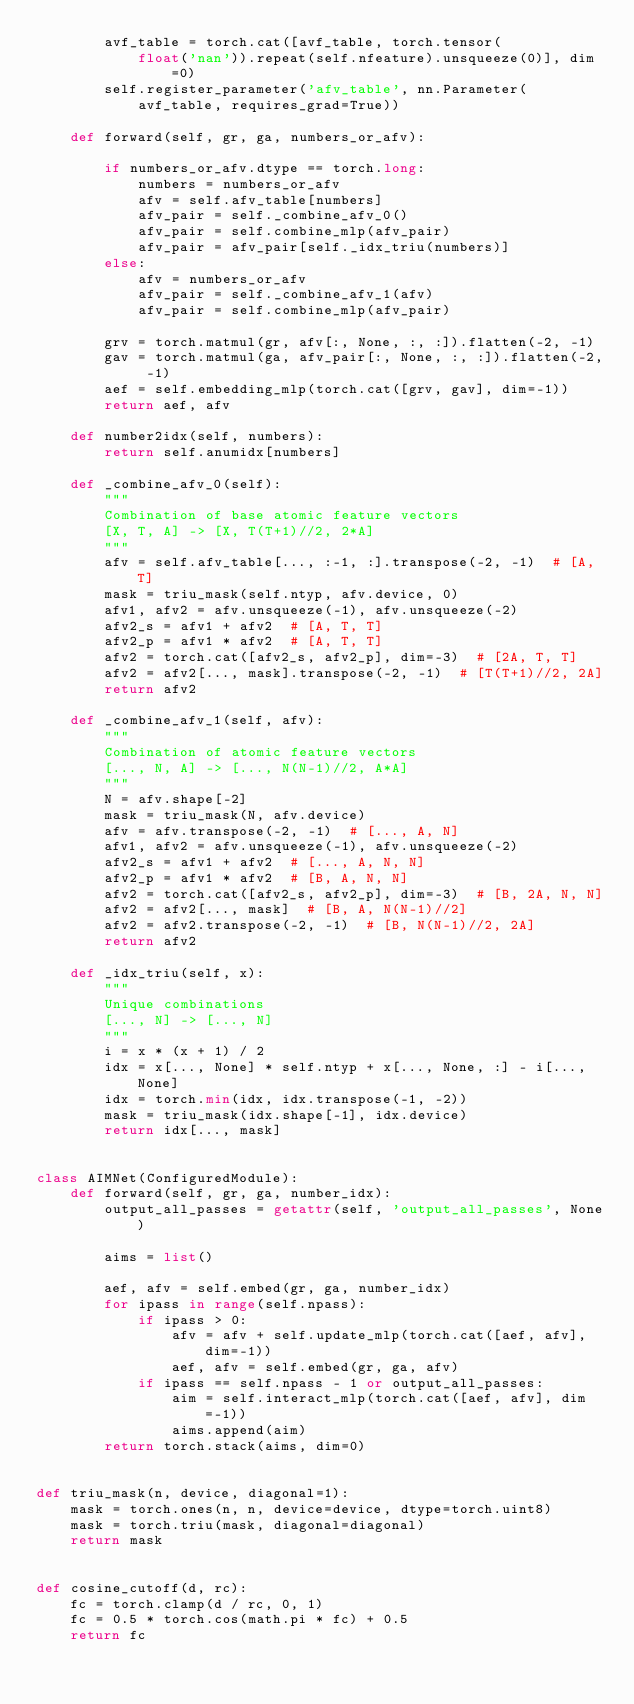Convert code to text. <code><loc_0><loc_0><loc_500><loc_500><_Python_>        avf_table = torch.cat([avf_table, torch.tensor(
            float('nan')).repeat(self.nfeature).unsqueeze(0)], dim=0)
        self.register_parameter('afv_table', nn.Parameter(
            avf_table, requires_grad=True))

    def forward(self, gr, ga, numbers_or_afv):

        if numbers_or_afv.dtype == torch.long:
            numbers = numbers_or_afv
            afv = self.afv_table[numbers]
            afv_pair = self._combine_afv_0()
            afv_pair = self.combine_mlp(afv_pair)
            afv_pair = afv_pair[self._idx_triu(numbers)]
        else:
            afv = numbers_or_afv
            afv_pair = self._combine_afv_1(afv)
            afv_pair = self.combine_mlp(afv_pair)

        grv = torch.matmul(gr, afv[:, None, :, :]).flatten(-2, -1)
        gav = torch.matmul(ga, afv_pair[:, None, :, :]).flatten(-2, -1)
        aef = self.embedding_mlp(torch.cat([grv, gav], dim=-1))
        return aef, afv

    def number2idx(self, numbers):
        return self.anumidx[numbers]

    def _combine_afv_0(self):
        """
        Combination of base atomic feature vectors
        [X, T, A] -> [X, T(T+1)//2, 2*A]
        """
        afv = self.afv_table[..., :-1, :].transpose(-2, -1)  # [A, T]
        mask = triu_mask(self.ntyp, afv.device, 0)
        afv1, afv2 = afv.unsqueeze(-1), afv.unsqueeze(-2)
        afv2_s = afv1 + afv2  # [A, T, T]
        afv2_p = afv1 * afv2  # [A, T, T]
        afv2 = torch.cat([afv2_s, afv2_p], dim=-3)  # [2A, T, T]
        afv2 = afv2[..., mask].transpose(-2, -1)  # [T(T+1)//2, 2A]
        return afv2

    def _combine_afv_1(self, afv):
        """
        Combination of atomic feature vectors
        [..., N, A] -> [..., N(N-1)//2, A*A]
        """
        N = afv.shape[-2]
        mask = triu_mask(N, afv.device)
        afv = afv.transpose(-2, -1)  # [..., A, N]
        afv1, afv2 = afv.unsqueeze(-1), afv.unsqueeze(-2)
        afv2_s = afv1 + afv2  # [..., A, N, N]
        afv2_p = afv1 * afv2  # [B, A, N, N]
        afv2 = torch.cat([afv2_s, afv2_p], dim=-3)  # [B, 2A, N, N]
        afv2 = afv2[..., mask]  # [B, A, N(N-1)//2]
        afv2 = afv2.transpose(-2, -1)  # [B, N(N-1)//2, 2A]
        return afv2

    def _idx_triu(self, x):
        """
        Unique combinations
        [..., N] -> [..., N]
        """
        i = x * (x + 1) / 2
        idx = x[..., None] * self.ntyp + x[..., None, :] - i[..., None]
        idx = torch.min(idx, idx.transpose(-1, -2))
        mask = triu_mask(idx.shape[-1], idx.device)
        return idx[..., mask]


class AIMNet(ConfiguredModule):
    def forward(self, gr, ga, number_idx):
        output_all_passes = getattr(self, 'output_all_passes', None)

        aims = list()

        aef, afv = self.embed(gr, ga, number_idx)
        for ipass in range(self.npass):
            if ipass > 0:
                afv = afv + self.update_mlp(torch.cat([aef, afv], dim=-1))
                aef, afv = self.embed(gr, ga, afv)
            if ipass == self.npass - 1 or output_all_passes:
                aim = self.interact_mlp(torch.cat([aef, afv], dim=-1))
                aims.append(aim)
        return torch.stack(aims, dim=0)


def triu_mask(n, device, diagonal=1):
    mask = torch.ones(n, n, device=device, dtype=torch.uint8)
    mask = torch.triu(mask, diagonal=diagonal)
    return mask


def cosine_cutoff(d, rc):
    fc = torch.clamp(d / rc, 0, 1)
    fc = 0.5 * torch.cos(math.pi * fc) + 0.5
    return fc

</code> 